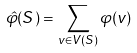Convert formula to latex. <formula><loc_0><loc_0><loc_500><loc_500>\hat { \varphi } ( S ) = \sum _ { v \in V ( S ) } \varphi ( v )</formula> 